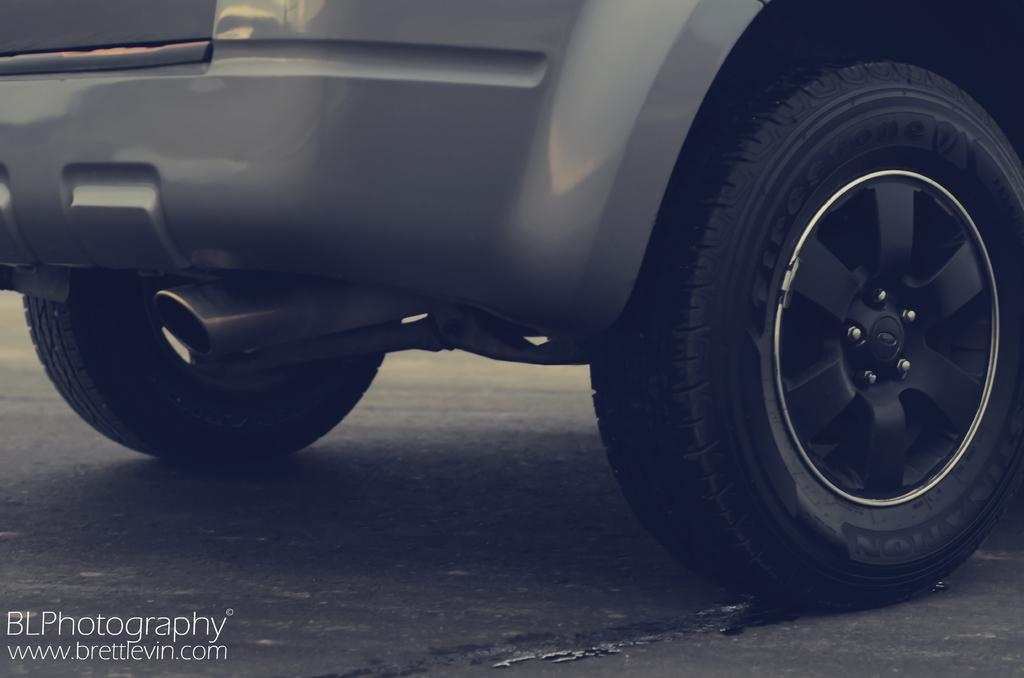What is the main subject of the image? There is a vehicle in the image. Can you describe any text present in the image? Yes, there is text in the bottom left-hand side of the image. What type of shoe is visible in the image? There is no shoe present in the image. Can you describe the yak's tongue in the image? There is no yak or tongue present in the image. 